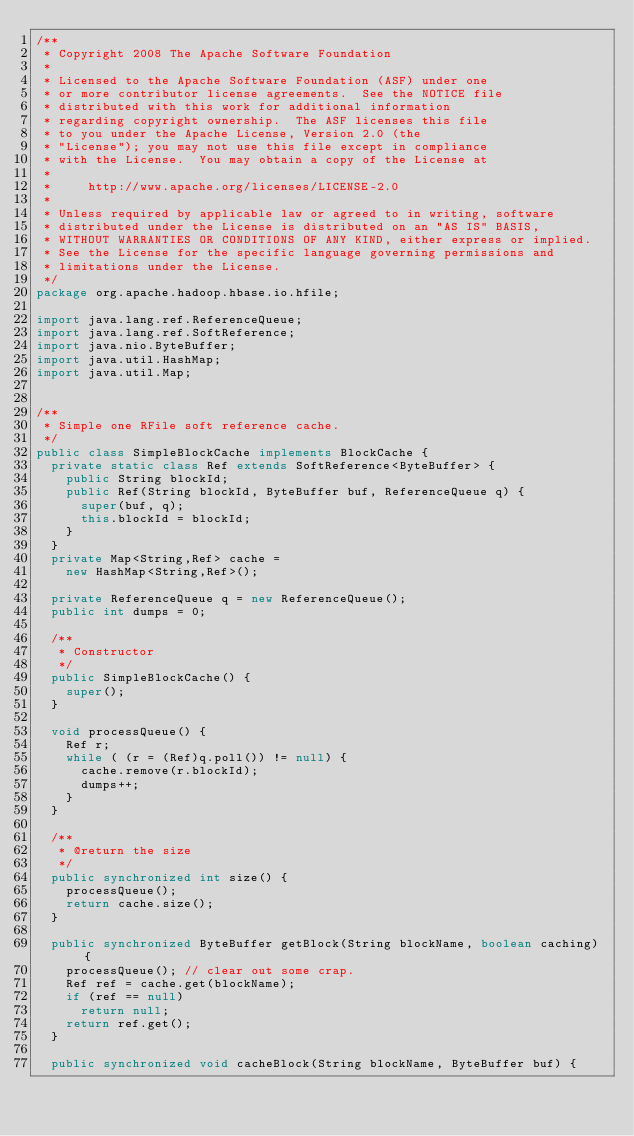Convert code to text. <code><loc_0><loc_0><loc_500><loc_500><_Java_>/**
 * Copyright 2008 The Apache Software Foundation
 *
 * Licensed to the Apache Software Foundation (ASF) under one
 * or more contributor license agreements.  See the NOTICE file
 * distributed with this work for additional information
 * regarding copyright ownership.  The ASF licenses this file
 * to you under the Apache License, Version 2.0 (the
 * "License"); you may not use this file except in compliance
 * with the License.  You may obtain a copy of the License at
 *
 *     http://www.apache.org/licenses/LICENSE-2.0
 *
 * Unless required by applicable law or agreed to in writing, software
 * distributed under the License is distributed on an "AS IS" BASIS,
 * WITHOUT WARRANTIES OR CONDITIONS OF ANY KIND, either express or implied.
 * See the License for the specific language governing permissions and
 * limitations under the License.
 */
package org.apache.hadoop.hbase.io.hfile;

import java.lang.ref.ReferenceQueue;
import java.lang.ref.SoftReference;
import java.nio.ByteBuffer;
import java.util.HashMap;
import java.util.Map;


/**
 * Simple one RFile soft reference cache.
 */
public class SimpleBlockCache implements BlockCache {
  private static class Ref extends SoftReference<ByteBuffer> {
    public String blockId;
    public Ref(String blockId, ByteBuffer buf, ReferenceQueue q) {
      super(buf, q);
      this.blockId = blockId;
    }
  }
  private Map<String,Ref> cache =
    new HashMap<String,Ref>();

  private ReferenceQueue q = new ReferenceQueue();
  public int dumps = 0;

  /**
   * Constructor
   */
  public SimpleBlockCache() {
    super();
  }

  void processQueue() {
    Ref r;
    while ( (r = (Ref)q.poll()) != null) {
      cache.remove(r.blockId);
      dumps++;
    }
  }

  /**
   * @return the size
   */
  public synchronized int size() {
    processQueue();
    return cache.size();
  }

  public synchronized ByteBuffer getBlock(String blockName, boolean caching) {
    processQueue(); // clear out some crap.
    Ref ref = cache.get(blockName);
    if (ref == null)
      return null;
    return ref.get();
  }

  public synchronized void cacheBlock(String blockName, ByteBuffer buf) {</code> 